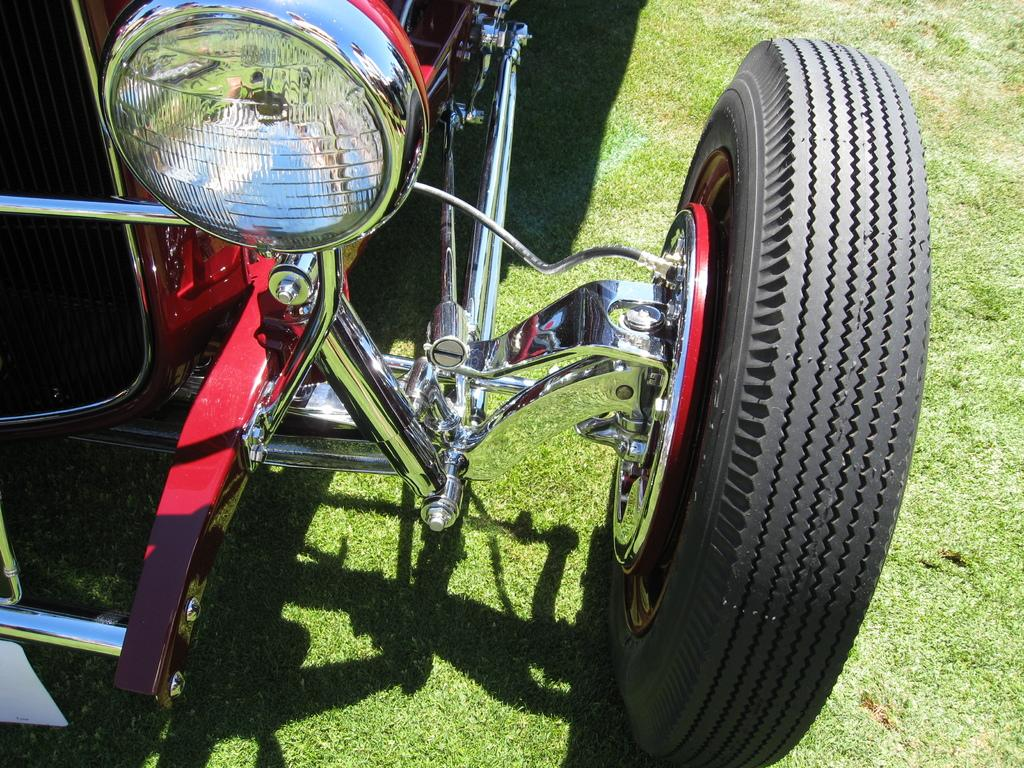What is the main subject of the image? There is a vehicle in the image. What colors can be seen on the vehicle? The vehicle has red, silver, and black colors. Where is the vehicle located in the image? The vehicle is on the ground. What type of surface is the vehicle on? There is grass visible on the ground. Can you see a toad hopping on the vehicle in the image? There is no toad present in the image, and therefore no such activity can be observed. 